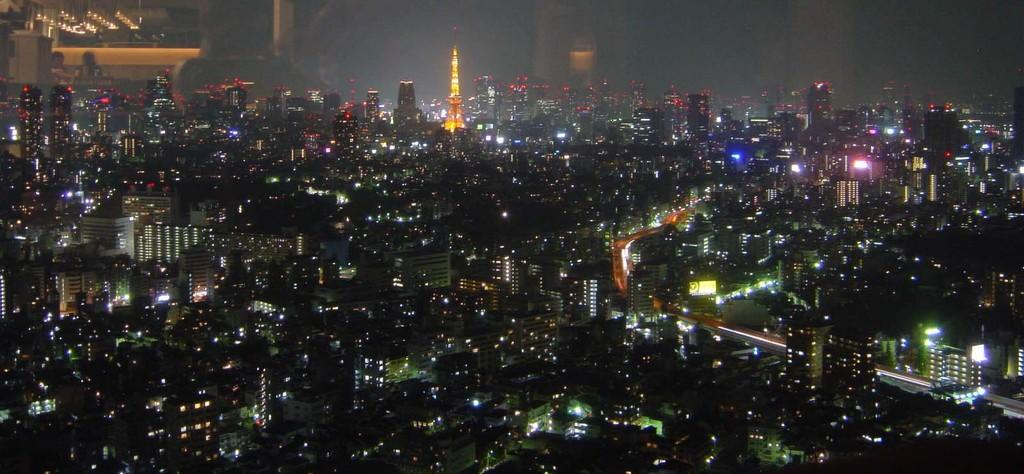What type of location is shown in the image? The image depicts a city. What structures can be seen in the city? There are multiple buildings in the image. What can be observed about the lighting in the image? There are lights visible in the image. Can you describe the yellow-colored tower in the image? Yes, there is a yellow-colored tower in the image. What is the color of the background in the image? The background of the image is dark. What part of the natural environment is visible in the image? The sky is visible in the image. How many friends can be seen playing a game in the image? There are no friends or games present in the image; it depicts a city with multiple buildings, lights, and a yellow-colored tower. 